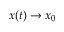<formula> <loc_0><loc_0><loc_500><loc_500>{ \boldsymbol x } ( t ) \to { \boldsymbol x } _ { 0 }</formula> 